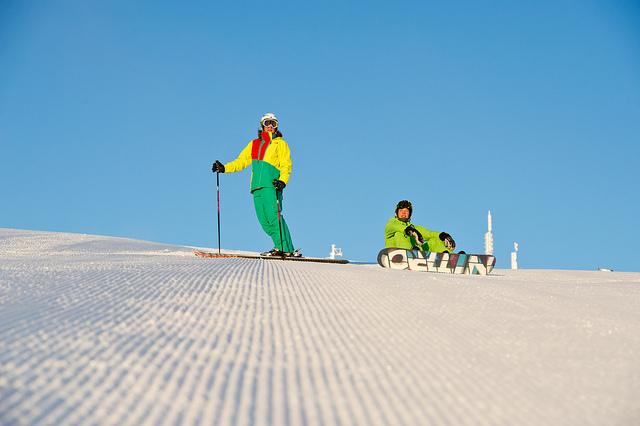What could the condition of the terrain be described as? snowy 